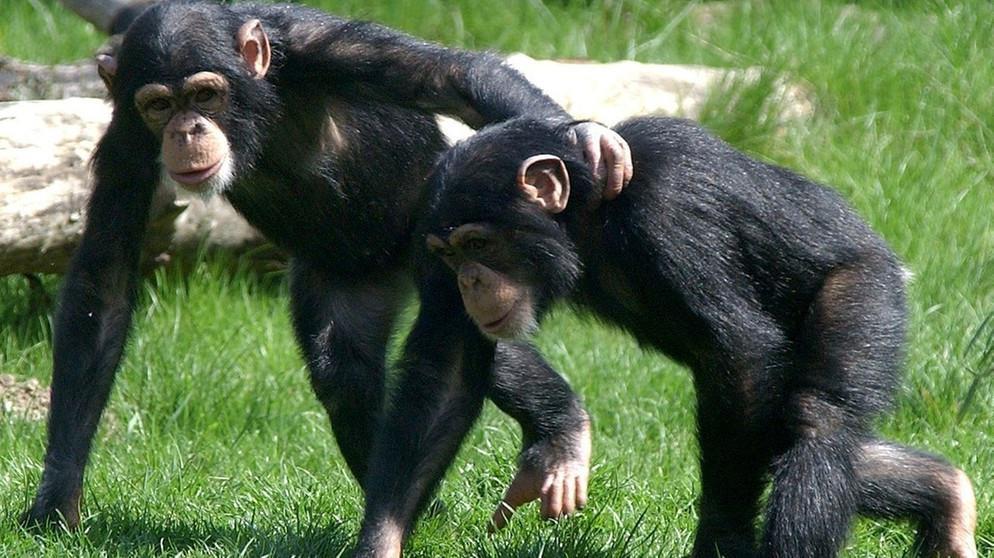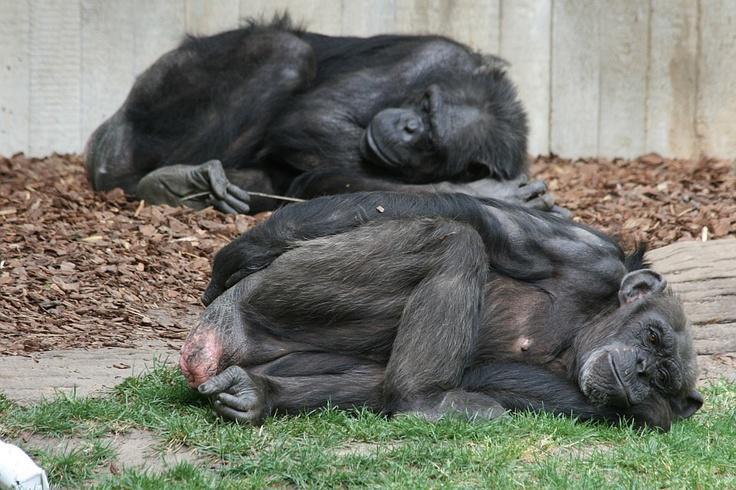The first image is the image on the left, the second image is the image on the right. Considering the images on both sides, is "Two primates are lying down in one of the images." valid? Answer yes or no. Yes. The first image is the image on the left, the second image is the image on the right. Assess this claim about the two images: "In one of the images there are exactly two chimpanzees laying down near each other..". Correct or not? Answer yes or no. Yes. 